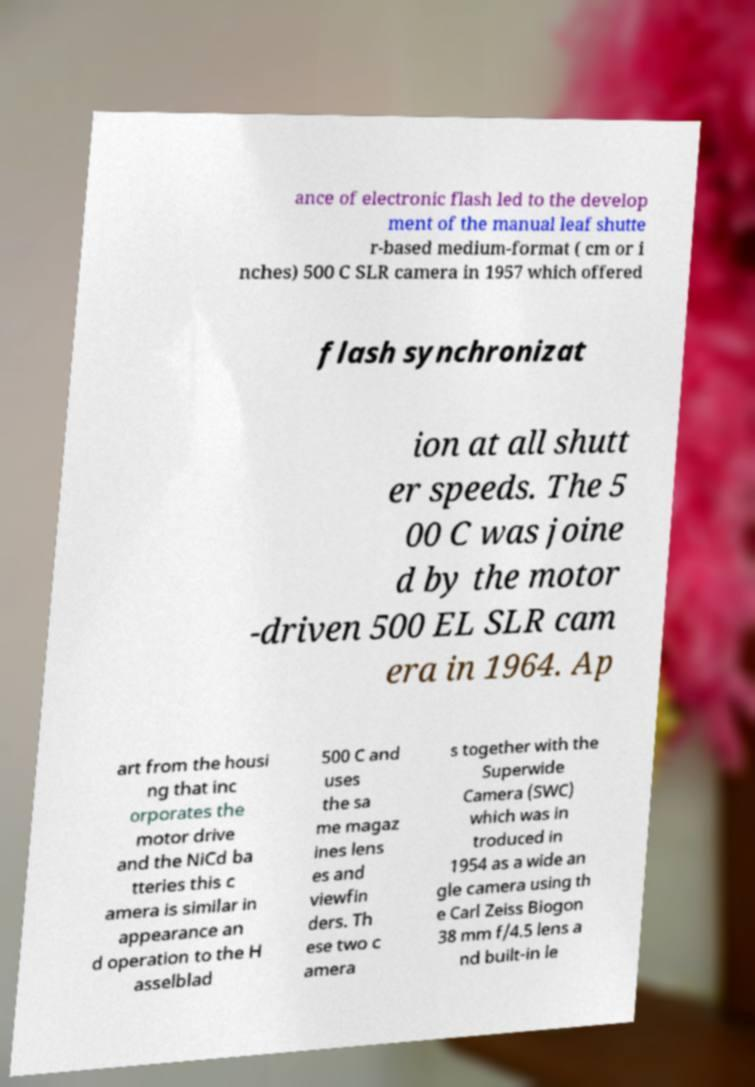Could you extract and type out the text from this image? ance of electronic flash led to the develop ment of the manual leaf shutte r-based medium-format ( cm or i nches) 500 C SLR camera in 1957 which offered flash synchronizat ion at all shutt er speeds. The 5 00 C was joine d by the motor -driven 500 EL SLR cam era in 1964. Ap art from the housi ng that inc orporates the motor drive and the NiCd ba tteries this c amera is similar in appearance an d operation to the H asselblad 500 C and uses the sa me magaz ines lens es and viewfin ders. Th ese two c amera s together with the Superwide Camera (SWC) which was in troduced in 1954 as a wide an gle camera using th e Carl Zeiss Biogon 38 mm f/4.5 lens a nd built-in le 